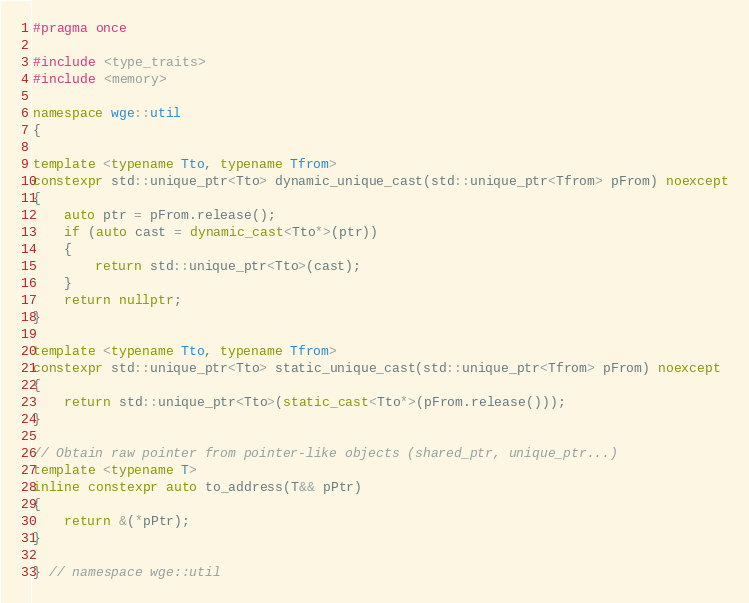Convert code to text. <code><loc_0><loc_0><loc_500><loc_500><_C++_>#pragma once

#include <type_traits>
#include <memory>

namespace wge::util
{

template <typename Tto, typename Tfrom>
constexpr std::unique_ptr<Tto> dynamic_unique_cast(std::unique_ptr<Tfrom> pFrom) noexcept
{
	auto ptr = pFrom.release();
	if (auto cast = dynamic_cast<Tto*>(ptr))
	{
		return std::unique_ptr<Tto>(cast);
	}
	return nullptr;
}

template <typename Tto, typename Tfrom>
constexpr std::unique_ptr<Tto> static_unique_cast(std::unique_ptr<Tfrom> pFrom) noexcept
{
	return std::unique_ptr<Tto>(static_cast<Tto*>(pFrom.release()));
}

// Obtain raw pointer from pointer-like objects (shared_ptr, unique_ptr...)
template <typename T>
inline constexpr auto to_address(T&& pPtr)
{
	return &(*pPtr);
}

} // namespace wge::util
</code> 